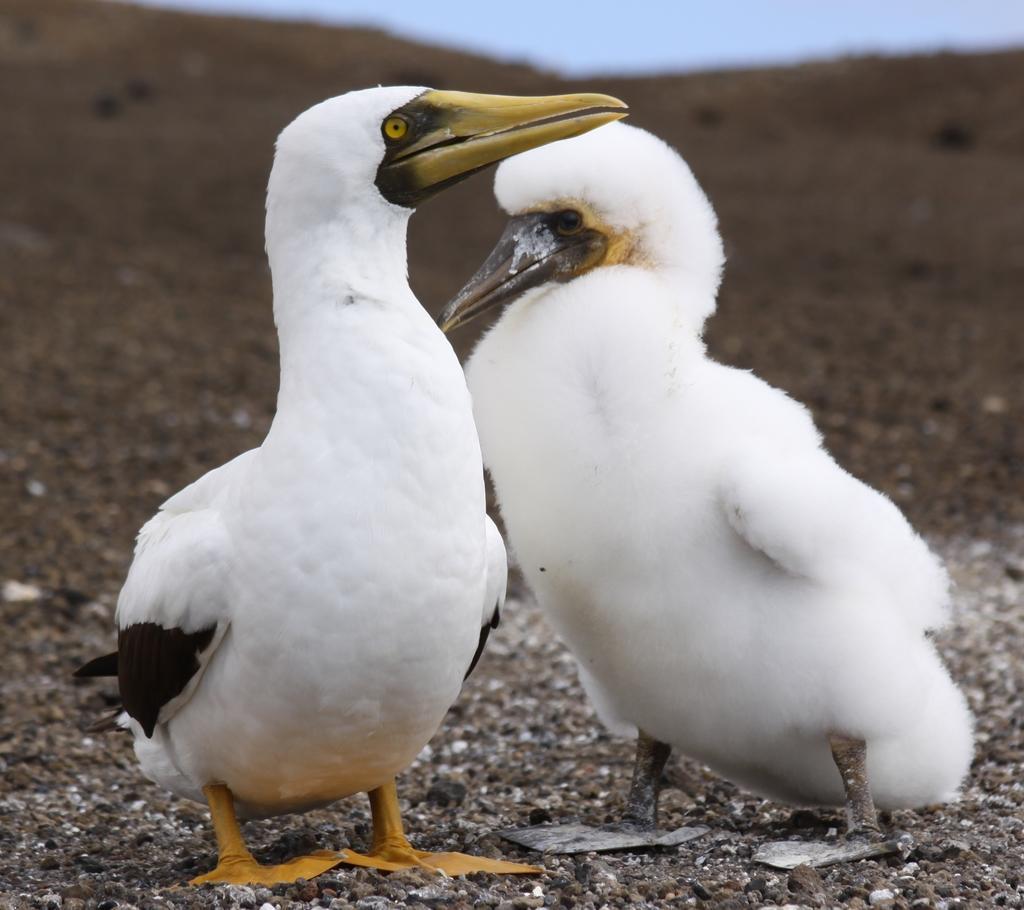Could you give a brief overview of what you see in this image? In this picture we can see two sea birds standing here, at the bottom there is soil, we can see the sky at the top of the picture. 